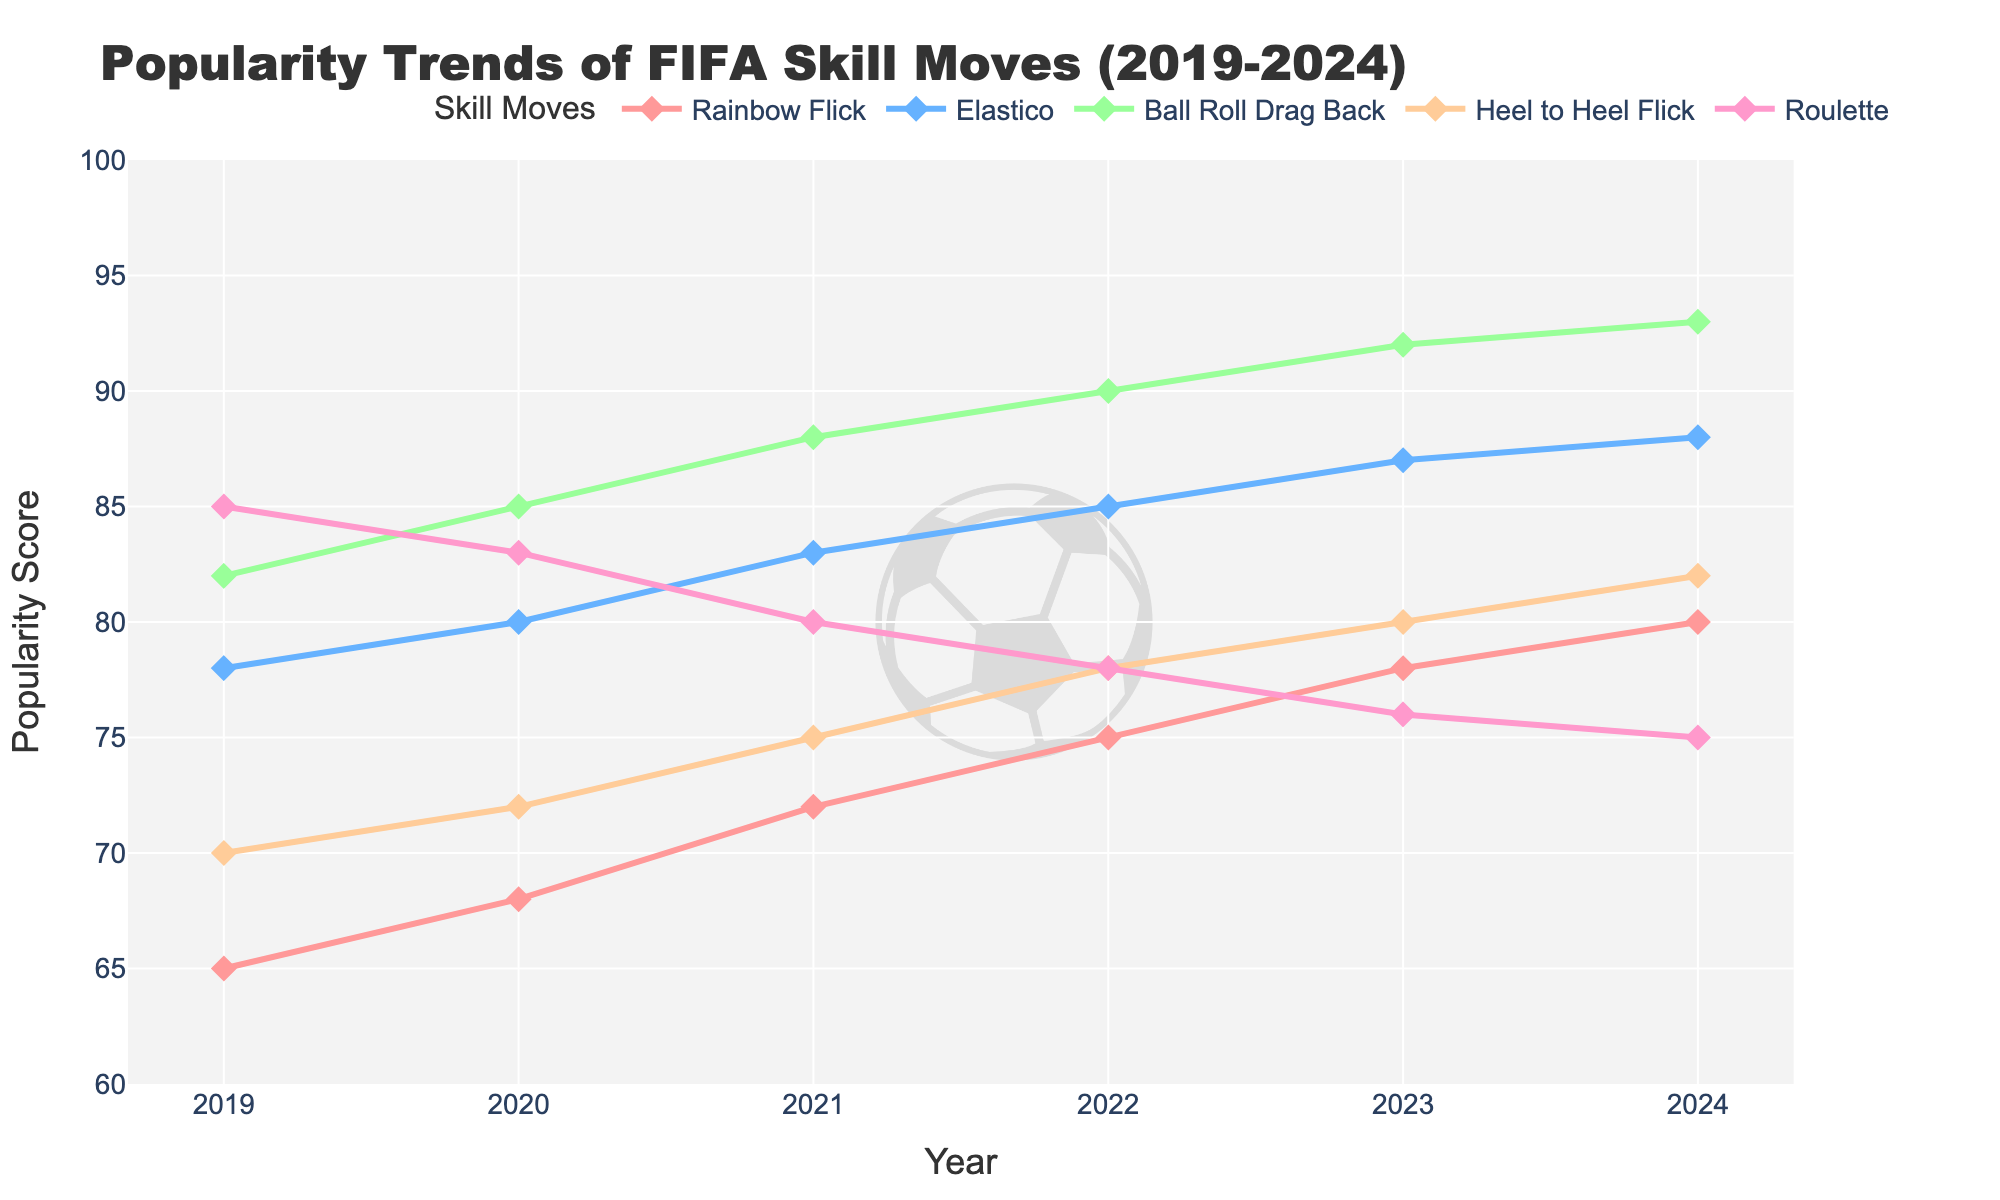Which skill move had the highest popularity in 2021? Look at the trend lines for 2021, and identify which line reaches the highest point. The 'Ball Roll Drag Back' reaches the highest point with a score of 88.
Answer: Ball Roll Drag Back How did the popularity of the 'Heel to Heel Flick' change from 2019 to 2024? Identify the data points for 'Heel to Heel Flick' in 2019 and 2024. In 2019, the popularity is 70, and in 2024, it is 82. The popularity increased by 12 points.
Answer: Increased by 12 points Which skill move had the smallest increase in popularity from 2022 to 2023? Compare the difference in popularity scores from 2022 to 2023 for all skill moves. 'Roulette' decreased from 78 to 76, which is a decrease, and the smallest increase is 'Heel to Heel Flick', which increased from 78 to 80 by 2 points.
Answer: Heel to Heel Flick In what year did the 'Roulette' skill move's popularity drop below 80? Look at the trend line for 'Roulette' and identify the years where the score is below 80. The score first drops below 80 in 2022, where it is 78.
Answer: 2022 Which skill moves had a consistent increase in popularity every year from 2019 to 2024? Examine each trend line to see if it increases every year. 'Ball Roll Drag Back' shows a consistent increase from 82 in 2019 to 93 in 2024.
Answer: Ball Roll Drag Back What is the difference in popularity between 'Elastico' and 'Heel to Heel Flick' in 2020? Look at the scores for 'Elastico' and 'Heel to Heel Flick' in 2020. 'Elastico' is 80 and 'Heel to Heel Flick' is 72. The difference is 80 - 72 = 8.
Answer: 8 Which skill move had the steepest rise in popularity between 2019 and 2024? Calculate the difference in popularity from 2019 to 2024 for each skill move. 'Ball Roll Drag Back' increased from 82 to 93, a rise of 11, which is the steepest among the skill moves.
Answer: Ball Roll Drag Back What's the average popularity of 'Rainbow Flick' from 2019 to 2024? Sum the popularity scores of 'Rainbow Flick' from 2019 to 2024 and divide by the number of years. The scores are 65, 68, 72, 75, 78, and 80. Sum = 438. Average = 438 / 6 = 73.
Answer: 73 Which year shows the largest gap in popularity between 'Elastico' and 'Roulette'? Find the year where the difference between the popularity scores of 'Elastico' and 'Roulette' is the greatest. In 2024, 'Elastico' is 88 and 'Roulette' is 75, with a gap of 13, the largest gap among the years.
Answer: 2024 How many skill moves surpassed a popularity score of 85 by 2024? Check the popularity scores for each skill move in 2024. 'Rainbow Flick' (80), 'Elastico' (88), 'Ball Roll Drag Back' (93), 'Heel to Heel Flick' (82), 'Roulette' (75). Only 'Elastico' and 'Ball Roll Drag Back' surpassed 85.
Answer: 2 